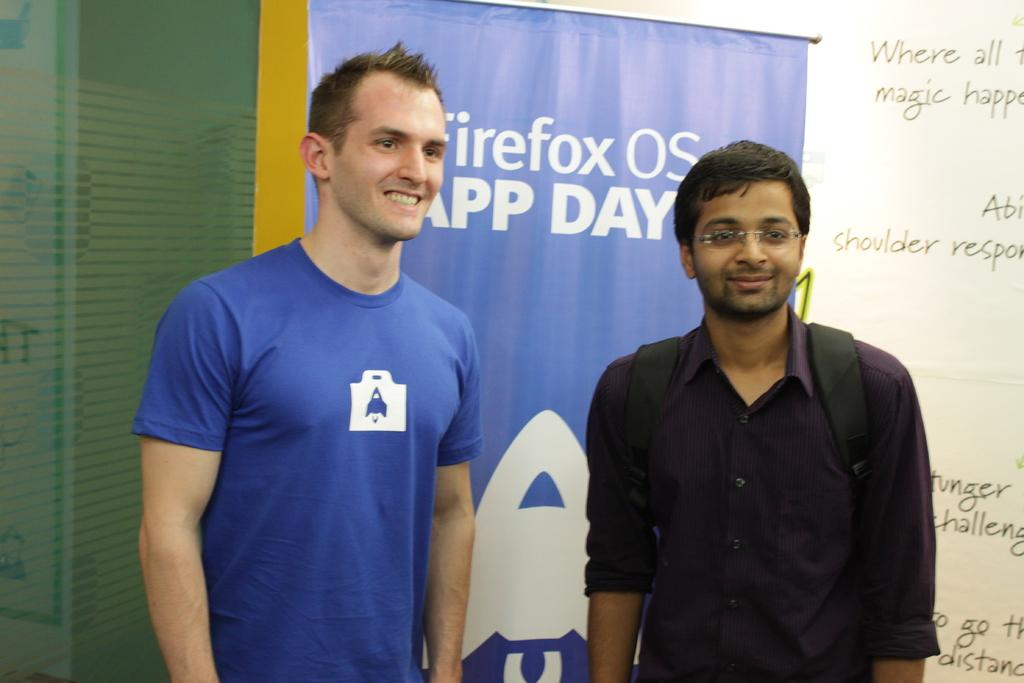How many people are present in the image? There are two people in the image. What is the facial expression of the people in the image? The people are smiling. What can be seen in the background of the image? There is a banner in the background of the image. What type of architectural feature is present on the left side of the image? There is a glass wall on the left side of the image. What type of balls are being used by the people in the image? There are no balls present in the image; the people are simply smiling. What is the taste of the banner in the background? Banners are not edible and therefore have no taste. 